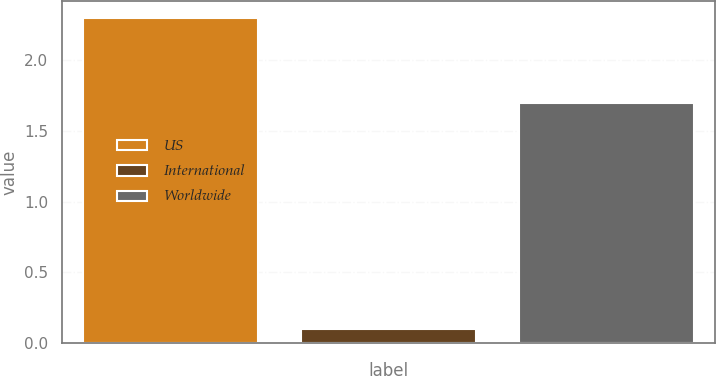Convert chart to OTSL. <chart><loc_0><loc_0><loc_500><loc_500><bar_chart><fcel>US<fcel>International<fcel>Worldwide<nl><fcel>2.3<fcel>0.1<fcel>1.7<nl></chart> 